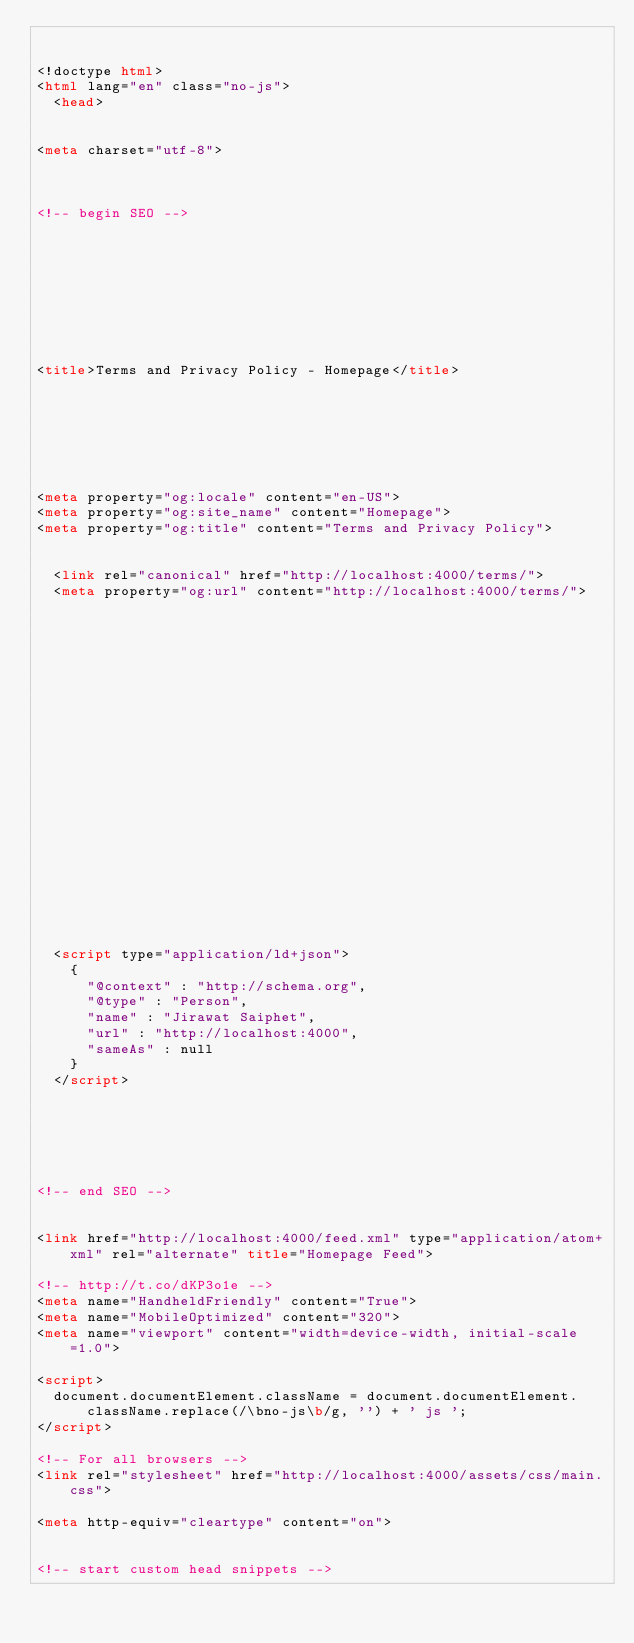Convert code to text. <code><loc_0><loc_0><loc_500><loc_500><_HTML_>

<!doctype html>
<html lang="en" class="no-js">
  <head>
    

<meta charset="utf-8">



<!-- begin SEO -->









<title>Terms and Privacy Policy - Homepage</title>







<meta property="og:locale" content="en-US">
<meta property="og:site_name" content="Homepage">
<meta property="og:title" content="Terms and Privacy Policy">


  <link rel="canonical" href="http://localhost:4000/terms/">
  <meta property="og:url" content="http://localhost:4000/terms/">







  

  












  <script type="application/ld+json">
    {
      "@context" : "http://schema.org",
      "@type" : "Person",
      "name" : "Jirawat Saiphet",
      "url" : "http://localhost:4000",
      "sameAs" : null
    }
  </script>






<!-- end SEO -->


<link href="http://localhost:4000/feed.xml" type="application/atom+xml" rel="alternate" title="Homepage Feed">

<!-- http://t.co/dKP3o1e -->
<meta name="HandheldFriendly" content="True">
<meta name="MobileOptimized" content="320">
<meta name="viewport" content="width=device-width, initial-scale=1.0">

<script>
  document.documentElement.className = document.documentElement.className.replace(/\bno-js\b/g, '') + ' js ';
</script>

<!-- For all browsers -->
<link rel="stylesheet" href="http://localhost:4000/assets/css/main.css">

<meta http-equiv="cleartype" content="on">
    

<!-- start custom head snippets -->
</code> 